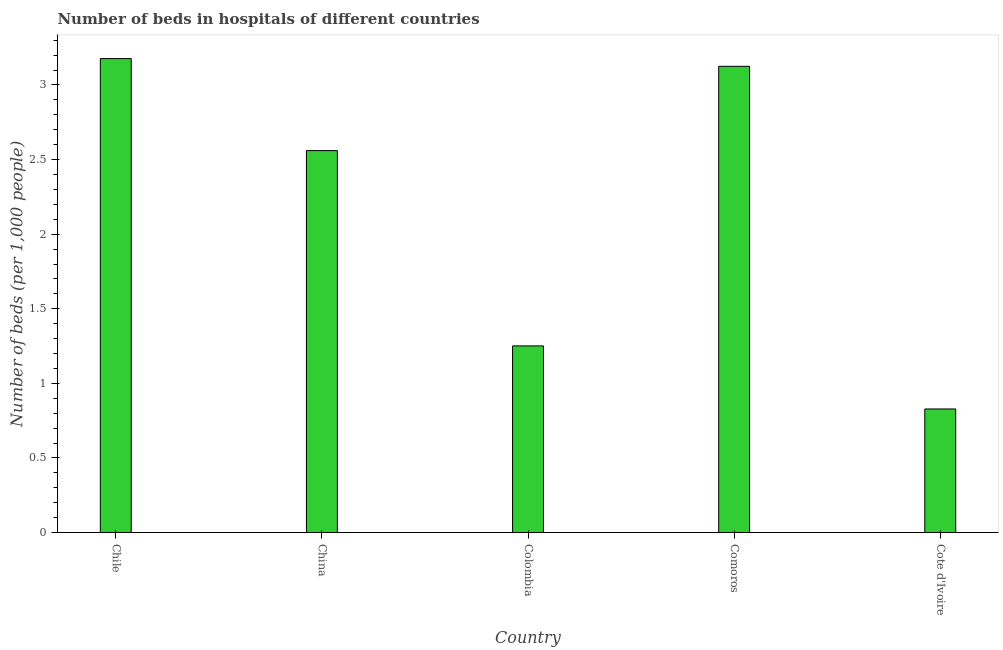Does the graph contain grids?
Your response must be concise. No. What is the title of the graph?
Provide a short and direct response. Number of beds in hospitals of different countries. What is the label or title of the Y-axis?
Ensure brevity in your answer.  Number of beds (per 1,0 people). What is the number of hospital beds in China?
Your answer should be compact. 2.56. Across all countries, what is the maximum number of hospital beds?
Your response must be concise. 3.18. Across all countries, what is the minimum number of hospital beds?
Offer a terse response. 0.83. In which country was the number of hospital beds maximum?
Offer a very short reply. Chile. In which country was the number of hospital beds minimum?
Your response must be concise. Cote d'Ivoire. What is the sum of the number of hospital beds?
Your answer should be compact. 10.94. What is the difference between the number of hospital beds in Chile and Colombia?
Offer a terse response. 1.93. What is the average number of hospital beds per country?
Your answer should be very brief. 2.19. What is the median number of hospital beds?
Ensure brevity in your answer.  2.56. In how many countries, is the number of hospital beds greater than 0.3 %?
Your response must be concise. 5. What is the ratio of the number of hospital beds in Chile to that in Cote d'Ivoire?
Give a very brief answer. 3.83. What is the difference between the highest and the second highest number of hospital beds?
Keep it short and to the point. 0.05. Is the sum of the number of hospital beds in Chile and Colombia greater than the maximum number of hospital beds across all countries?
Ensure brevity in your answer.  Yes. What is the difference between the highest and the lowest number of hospital beds?
Offer a terse response. 2.35. In how many countries, is the number of hospital beds greater than the average number of hospital beds taken over all countries?
Ensure brevity in your answer.  3. Are all the bars in the graph horizontal?
Your answer should be compact. No. How many countries are there in the graph?
Offer a terse response. 5. What is the difference between two consecutive major ticks on the Y-axis?
Ensure brevity in your answer.  0.5. What is the Number of beds (per 1,000 people) in Chile?
Keep it short and to the point. 3.18. What is the Number of beds (per 1,000 people) of China?
Your response must be concise. 2.56. What is the Number of beds (per 1,000 people) of Colombia?
Your response must be concise. 1.25. What is the Number of beds (per 1,000 people) in Comoros?
Your answer should be compact. 3.12. What is the Number of beds (per 1,000 people) of Cote d'Ivoire?
Your response must be concise. 0.83. What is the difference between the Number of beds (per 1,000 people) in Chile and China?
Your answer should be compact. 0.62. What is the difference between the Number of beds (per 1,000 people) in Chile and Colombia?
Your response must be concise. 1.93. What is the difference between the Number of beds (per 1,000 people) in Chile and Comoros?
Provide a short and direct response. 0.05. What is the difference between the Number of beds (per 1,000 people) in Chile and Cote d'Ivoire?
Your answer should be compact. 2.35. What is the difference between the Number of beds (per 1,000 people) in China and Colombia?
Make the answer very short. 1.31. What is the difference between the Number of beds (per 1,000 people) in China and Comoros?
Offer a terse response. -0.56. What is the difference between the Number of beds (per 1,000 people) in China and Cote d'Ivoire?
Offer a terse response. 1.73. What is the difference between the Number of beds (per 1,000 people) in Colombia and Comoros?
Your answer should be compact. -1.87. What is the difference between the Number of beds (per 1,000 people) in Colombia and Cote d'Ivoire?
Make the answer very short. 0.42. What is the difference between the Number of beds (per 1,000 people) in Comoros and Cote d'Ivoire?
Provide a short and direct response. 2.3. What is the ratio of the Number of beds (per 1,000 people) in Chile to that in China?
Provide a succinct answer. 1.24. What is the ratio of the Number of beds (per 1,000 people) in Chile to that in Colombia?
Give a very brief answer. 2.54. What is the ratio of the Number of beds (per 1,000 people) in Chile to that in Comoros?
Your response must be concise. 1.02. What is the ratio of the Number of beds (per 1,000 people) in Chile to that in Cote d'Ivoire?
Your response must be concise. 3.83. What is the ratio of the Number of beds (per 1,000 people) in China to that in Colombia?
Your answer should be very brief. 2.05. What is the ratio of the Number of beds (per 1,000 people) in China to that in Comoros?
Provide a succinct answer. 0.82. What is the ratio of the Number of beds (per 1,000 people) in China to that in Cote d'Ivoire?
Make the answer very short. 3.09. What is the ratio of the Number of beds (per 1,000 people) in Colombia to that in Comoros?
Your response must be concise. 0.4. What is the ratio of the Number of beds (per 1,000 people) in Colombia to that in Cote d'Ivoire?
Keep it short and to the point. 1.51. What is the ratio of the Number of beds (per 1,000 people) in Comoros to that in Cote d'Ivoire?
Make the answer very short. 3.77. 